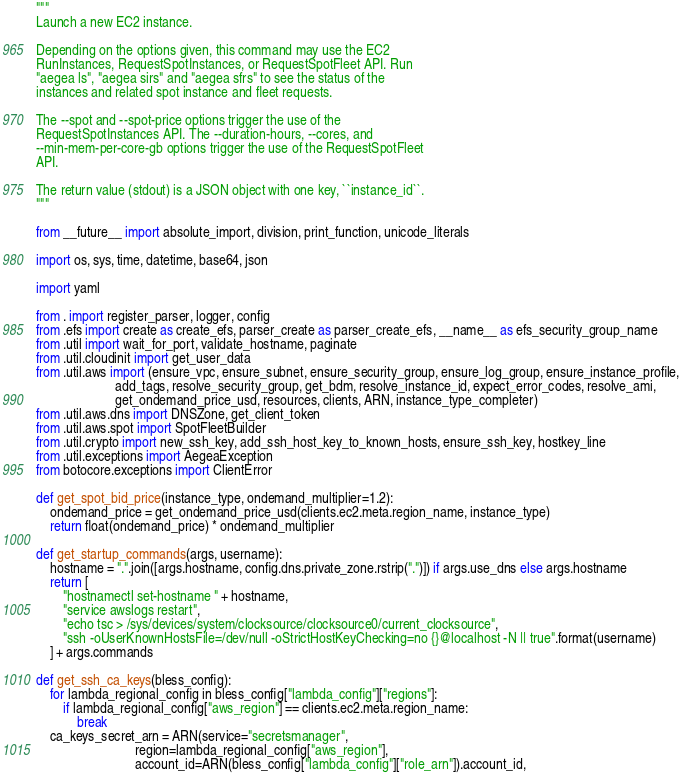<code> <loc_0><loc_0><loc_500><loc_500><_Python_>"""
Launch a new EC2 instance.

Depending on the options given, this command may use the EC2
RunInstances, RequestSpotInstances, or RequestSpotFleet API. Run
"aegea ls", "aegea sirs" and "aegea sfrs" to see the status of the
instances and related spot instance and fleet requests.

The --spot and --spot-price options trigger the use of the
RequestSpotInstances API. The --duration-hours, --cores, and
--min-mem-per-core-gb options trigger the use of the RequestSpotFleet
API.

The return value (stdout) is a JSON object with one key, ``instance_id``.
"""

from __future__ import absolute_import, division, print_function, unicode_literals

import os, sys, time, datetime, base64, json

import yaml

from . import register_parser, logger, config
from .efs import create as create_efs, parser_create as parser_create_efs, __name__ as efs_security_group_name
from .util import wait_for_port, validate_hostname, paginate
from .util.cloudinit import get_user_data
from .util.aws import (ensure_vpc, ensure_subnet, ensure_security_group, ensure_log_group, ensure_instance_profile,
                       add_tags, resolve_security_group, get_bdm, resolve_instance_id, expect_error_codes, resolve_ami,
                       get_ondemand_price_usd, resources, clients, ARN, instance_type_completer)
from .util.aws.dns import DNSZone, get_client_token
from .util.aws.spot import SpotFleetBuilder
from .util.crypto import new_ssh_key, add_ssh_host_key_to_known_hosts, ensure_ssh_key, hostkey_line
from .util.exceptions import AegeaException
from botocore.exceptions import ClientError

def get_spot_bid_price(instance_type, ondemand_multiplier=1.2):
    ondemand_price = get_ondemand_price_usd(clients.ec2.meta.region_name, instance_type)
    return float(ondemand_price) * ondemand_multiplier

def get_startup_commands(args, username):
    hostname = ".".join([args.hostname, config.dns.private_zone.rstrip(".")]) if args.use_dns else args.hostname
    return [
        "hostnamectl set-hostname " + hostname,
        "service awslogs restart",
        "echo tsc > /sys/devices/system/clocksource/clocksource0/current_clocksource",
        "ssh -oUserKnownHostsFile=/dev/null -oStrictHostKeyChecking=no {}@localhost -N || true".format(username)
    ] + args.commands

def get_ssh_ca_keys(bless_config):
    for lambda_regional_config in bless_config["lambda_config"]["regions"]:
        if lambda_regional_config["aws_region"] == clients.ec2.meta.region_name:
            break
    ca_keys_secret_arn = ARN(service="secretsmanager",
                             region=lambda_regional_config["aws_region"],
                             account_id=ARN(bless_config["lambda_config"]["role_arn"]).account_id,</code> 